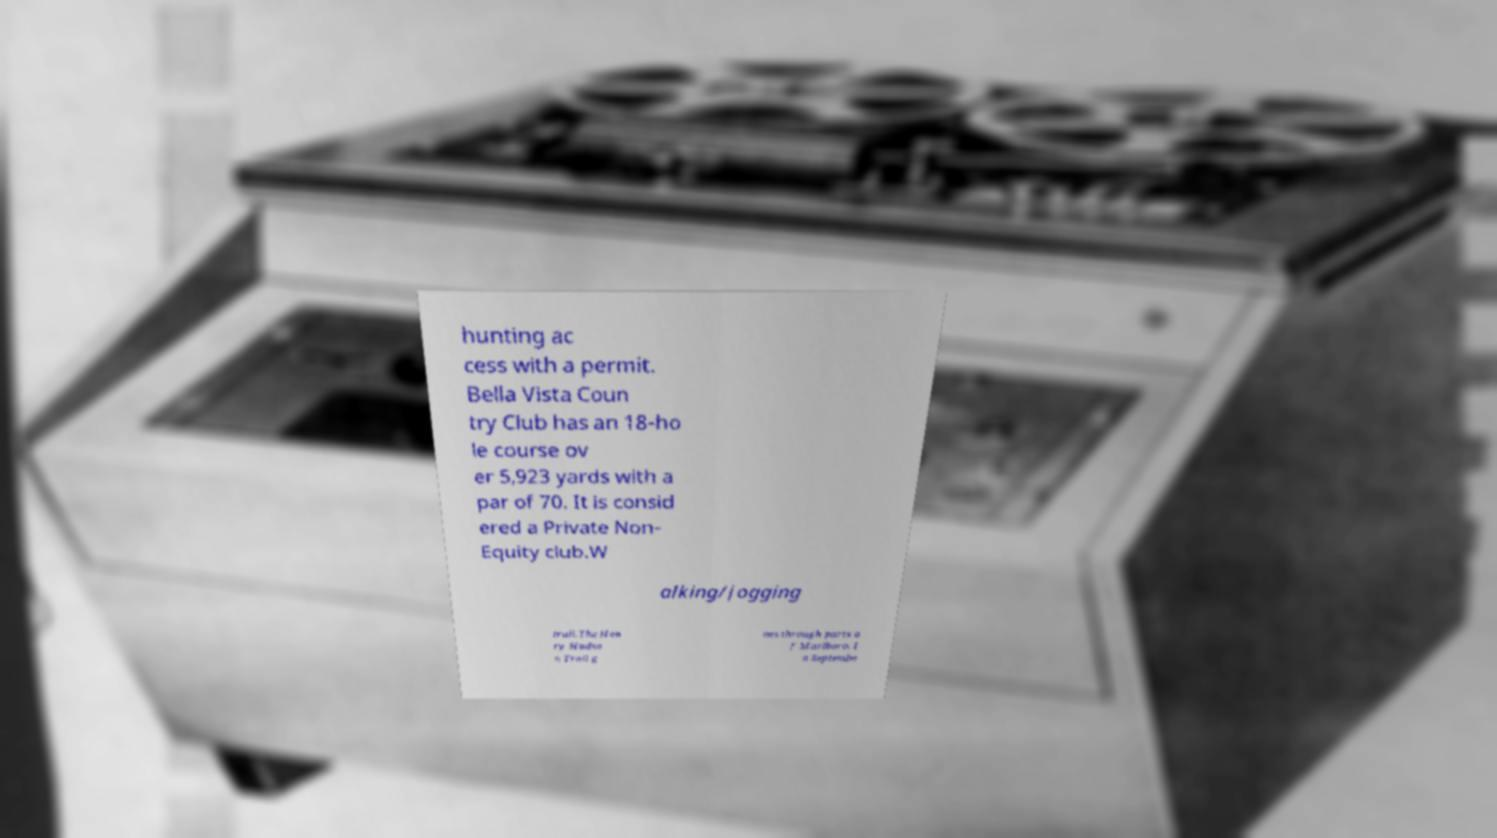There's text embedded in this image that I need extracted. Can you transcribe it verbatim? hunting ac cess with a permit. Bella Vista Coun try Club has an 18-ho le course ov er 5,923 yards with a par of 70. It is consid ered a Private Non- Equity club.W alking/jogging trail.The Hen ry Hudso n Trail g oes through parts o f Marlboro. I n Septembe 